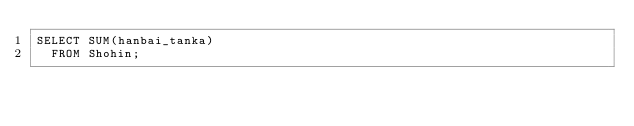<code> <loc_0><loc_0><loc_500><loc_500><_SQL_>SELECT SUM(hanbai_tanka)
  FROM Shohin;</code> 